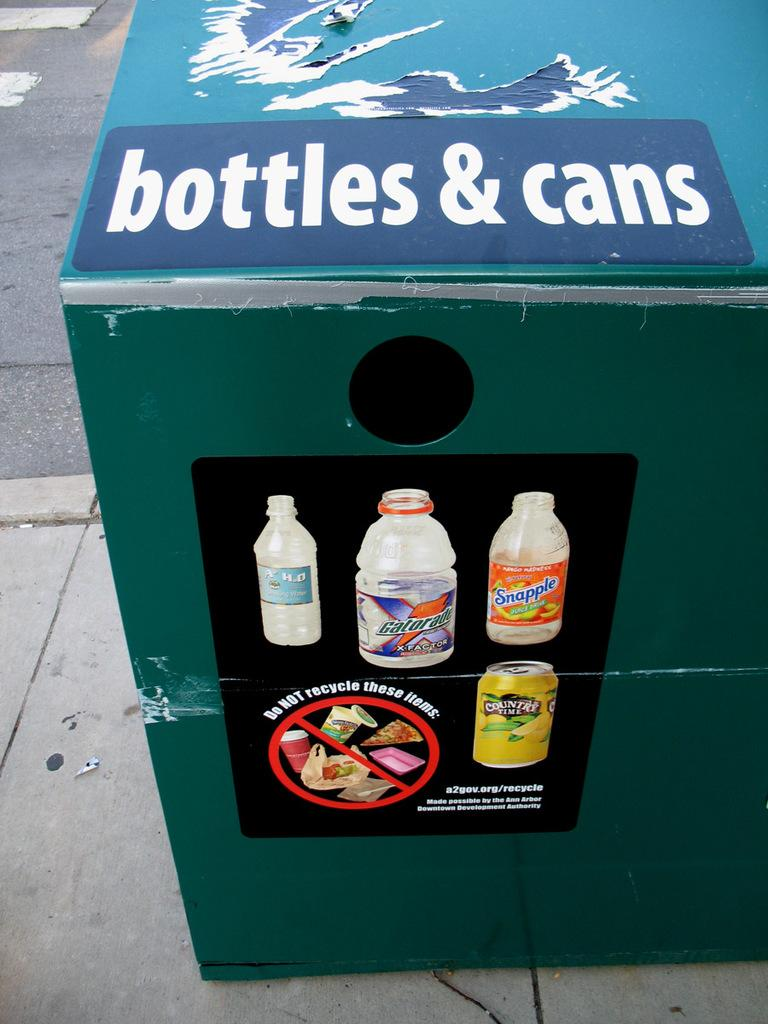<image>
Give a short and clear explanation of the subsequent image. a huge bin that is labeled 'bottles & cans' on the side of it 